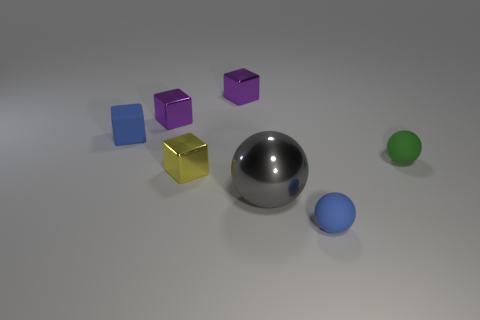There is a blue rubber sphere; does it have the same size as the gray thing in front of the green rubber sphere?
Your answer should be compact. No. Are the tiny block that is in front of the blue cube and the blue thing that is behind the tiny green rubber sphere made of the same material?
Give a very brief answer. No. Are there the same number of large objects that are left of the big ball and things that are left of the green rubber sphere?
Ensure brevity in your answer.  No. How many other large metal things are the same color as the big object?
Your response must be concise. 0. How many rubber things are blue objects or blue spheres?
Provide a short and direct response. 2. Is the shape of the matte object left of the large gray sphere the same as the tiny matte object right of the blue matte ball?
Keep it short and to the point. No. There is a blue ball; how many tiny spheres are to the right of it?
Your answer should be very brief. 1. Is there a small blue thing made of the same material as the small green object?
Your answer should be very brief. Yes. What is the material of the yellow object that is the same size as the blue rubber cube?
Offer a terse response. Metal. Does the tiny yellow object have the same material as the blue ball?
Provide a short and direct response. No. 